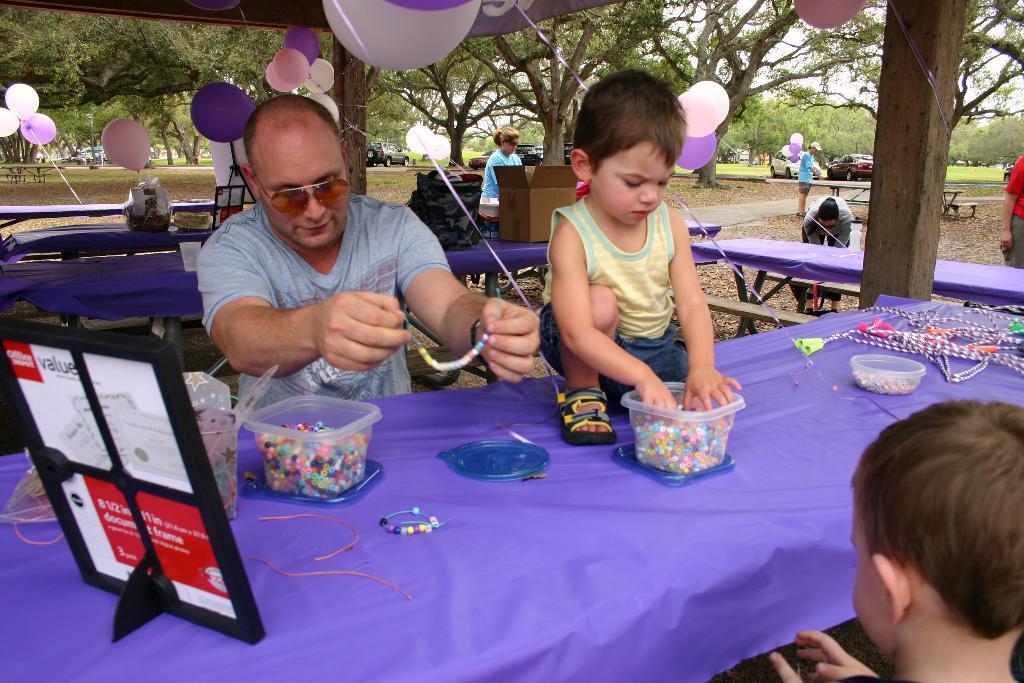Can you describe this image briefly? In this picture there is a man and a boy holding an object. There is a bowl. There is a frame. There is also another person. There are few objects and a purple cloth on the table. There are some balloons which are pink, purple and white in color. There is a man holding balloons and standing. There is a woman sitting on the chair. There is a box and bag on the table. There are some cars, trees, bench at the background. 